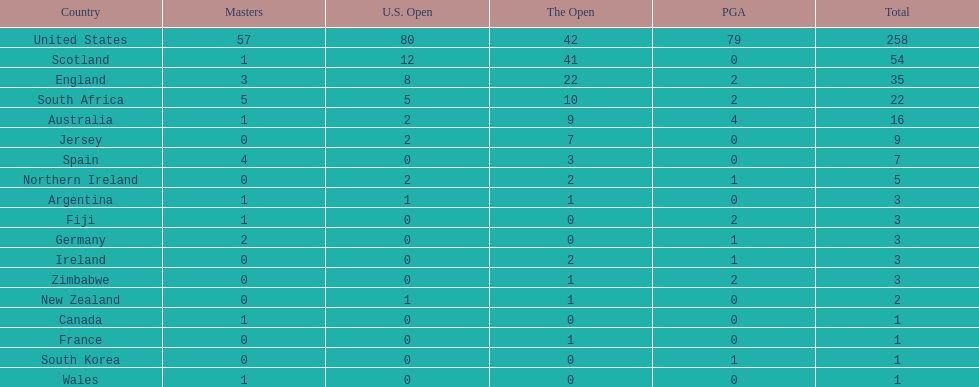Combined, how many winning golfers does england and wales have in the masters? 4. 